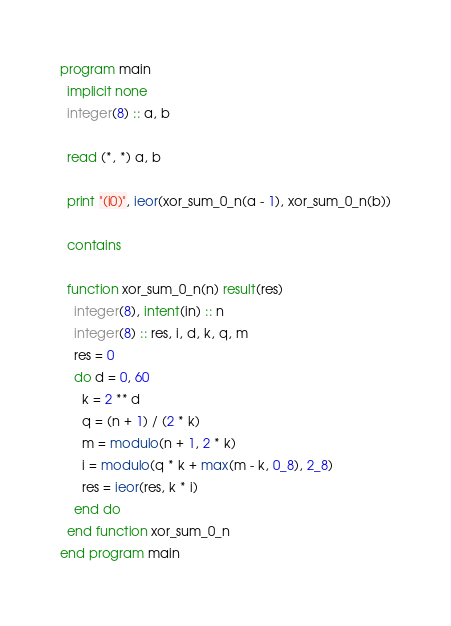Convert code to text. <code><loc_0><loc_0><loc_500><loc_500><_FORTRAN_>program main
  implicit none
  integer(8) :: a, b

  read (*, *) a, b

  print "(i0)", ieor(xor_sum_0_n(a - 1), xor_sum_0_n(b))

  contains

  function xor_sum_0_n(n) result(res)
    integer(8), intent(in) :: n
    integer(8) :: res, i, d, k, q, m
    res = 0
    do d = 0, 60
      k = 2 ** d
      q = (n + 1) / (2 * k)
      m = modulo(n + 1, 2 * k)
      i = modulo(q * k + max(m - k, 0_8), 2_8)
      res = ieor(res, k * i)
    end do
  end function xor_sum_0_n
end program main
</code> 